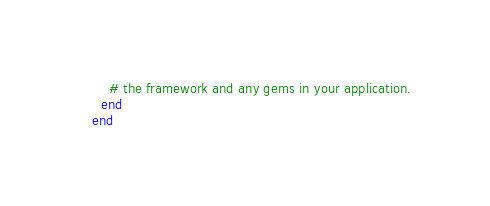<code> <loc_0><loc_0><loc_500><loc_500><_Ruby_>    # the framework and any gems in your application.
  end
end
</code> 